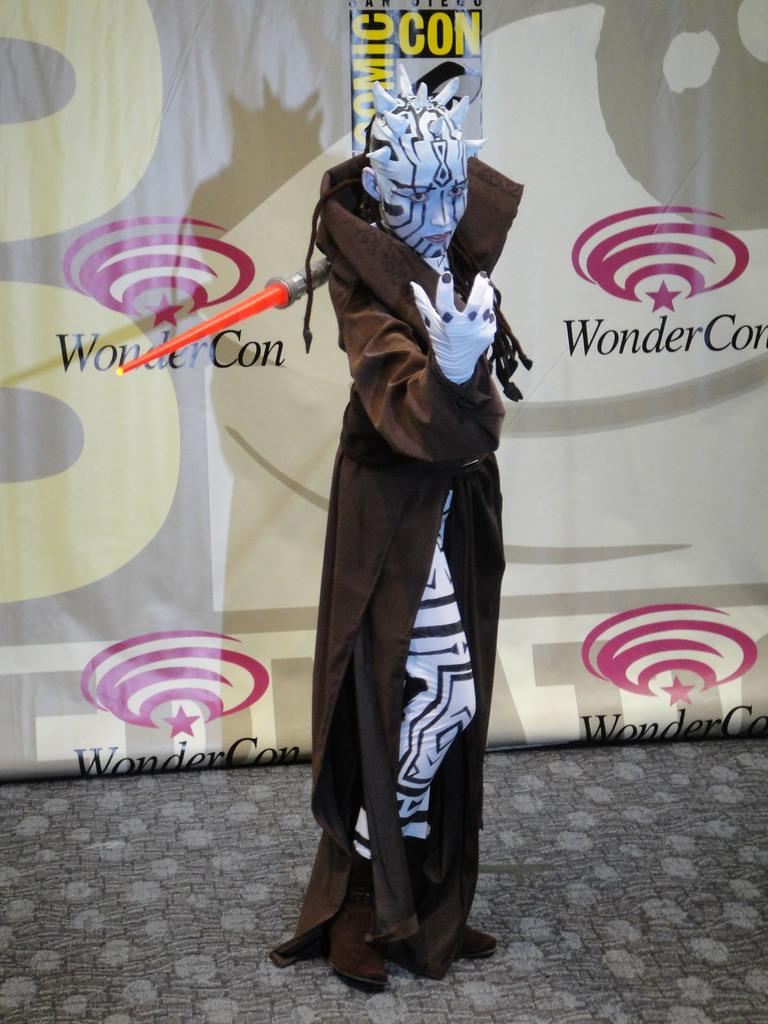What is the person in the image wearing? The person in the image is wearing a costume. Can you describe the object near the person? Unfortunately, the provided facts do not give any information about the object near the person. What can be seen in the background of the image? There is a banner with text and logos in the background of the image. What type of sidewalk can be seen in the image? There is no sidewalk present in the image. Can you describe the mist in the image? There is no mist present in the image. 